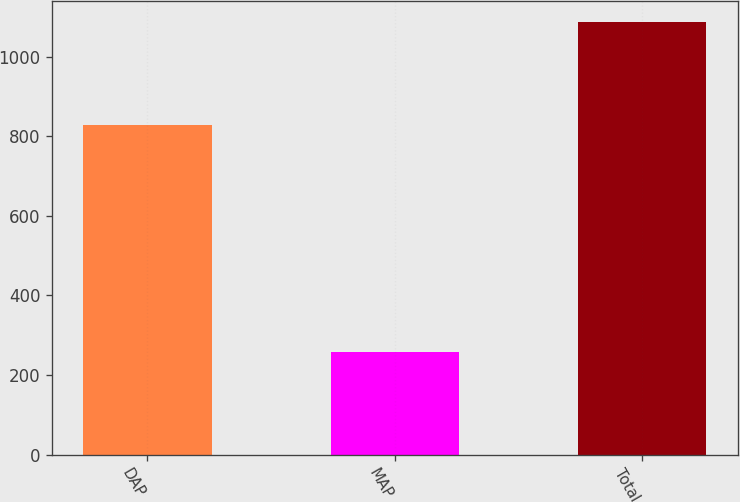Convert chart to OTSL. <chart><loc_0><loc_0><loc_500><loc_500><bar_chart><fcel>DAP<fcel>MAP<fcel>Total<nl><fcel>829.1<fcel>256.7<fcel>1085.8<nl></chart> 